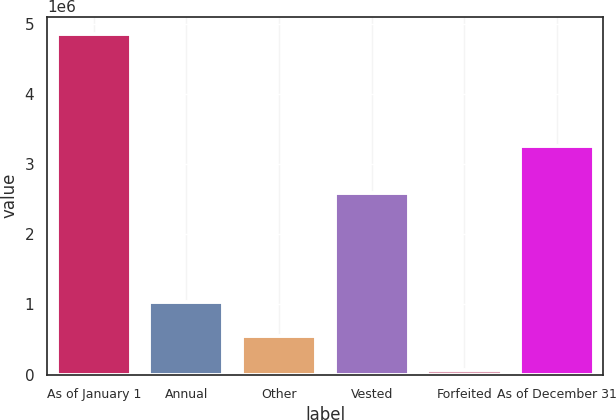<chart> <loc_0><loc_0><loc_500><loc_500><bar_chart><fcel>As of January 1<fcel>Annual<fcel>Other<fcel>Vested<fcel>Forfeited<fcel>As of December 31<nl><fcel>4.85897e+06<fcel>1.02844e+06<fcel>549618<fcel>2.59447e+06<fcel>70801<fcel>3.26156e+06<nl></chart> 